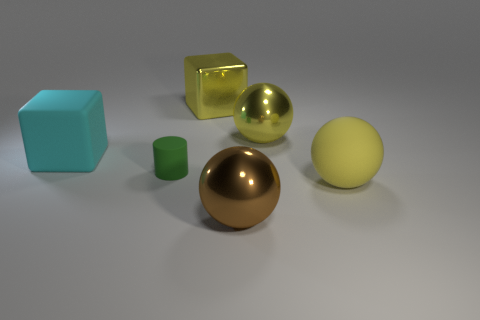Is there a big yellow matte ball?
Offer a terse response. Yes. What size is the shiny sphere that is in front of the big metal object right of the brown shiny sphere?
Offer a very short reply. Large. There is a big metal ball that is behind the big brown thing; does it have the same color as the big ball in front of the big matte sphere?
Offer a terse response. No. The large metallic thing that is behind the big brown shiny object and in front of the big yellow metal cube is what color?
Provide a short and direct response. Yellow. What number of other objects are there of the same shape as the green object?
Keep it short and to the point. 0. The other rubber object that is the same size as the cyan object is what color?
Keep it short and to the point. Yellow. What is the color of the big matte thing right of the large brown thing?
Give a very brief answer. Yellow. Is there a big sphere in front of the brown metallic ball on the right side of the small green cylinder?
Give a very brief answer. No. Do the big cyan rubber object and the large metal thing on the right side of the brown sphere have the same shape?
Offer a terse response. No. How big is the matte thing that is both right of the cyan matte block and left of the large matte ball?
Your response must be concise. Small. 